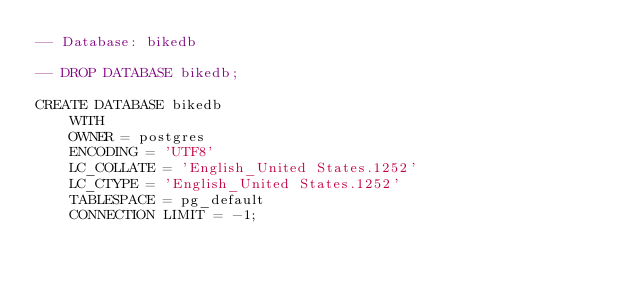Convert code to text. <code><loc_0><loc_0><loc_500><loc_500><_SQL_>-- Database: bikedb

-- DROP DATABASE bikedb;

CREATE DATABASE bikedb
    WITH 
    OWNER = postgres
    ENCODING = 'UTF8'
    LC_COLLATE = 'English_United States.1252'
    LC_CTYPE = 'English_United States.1252'
    TABLESPACE = pg_default
    CONNECTION LIMIT = -1;</code> 